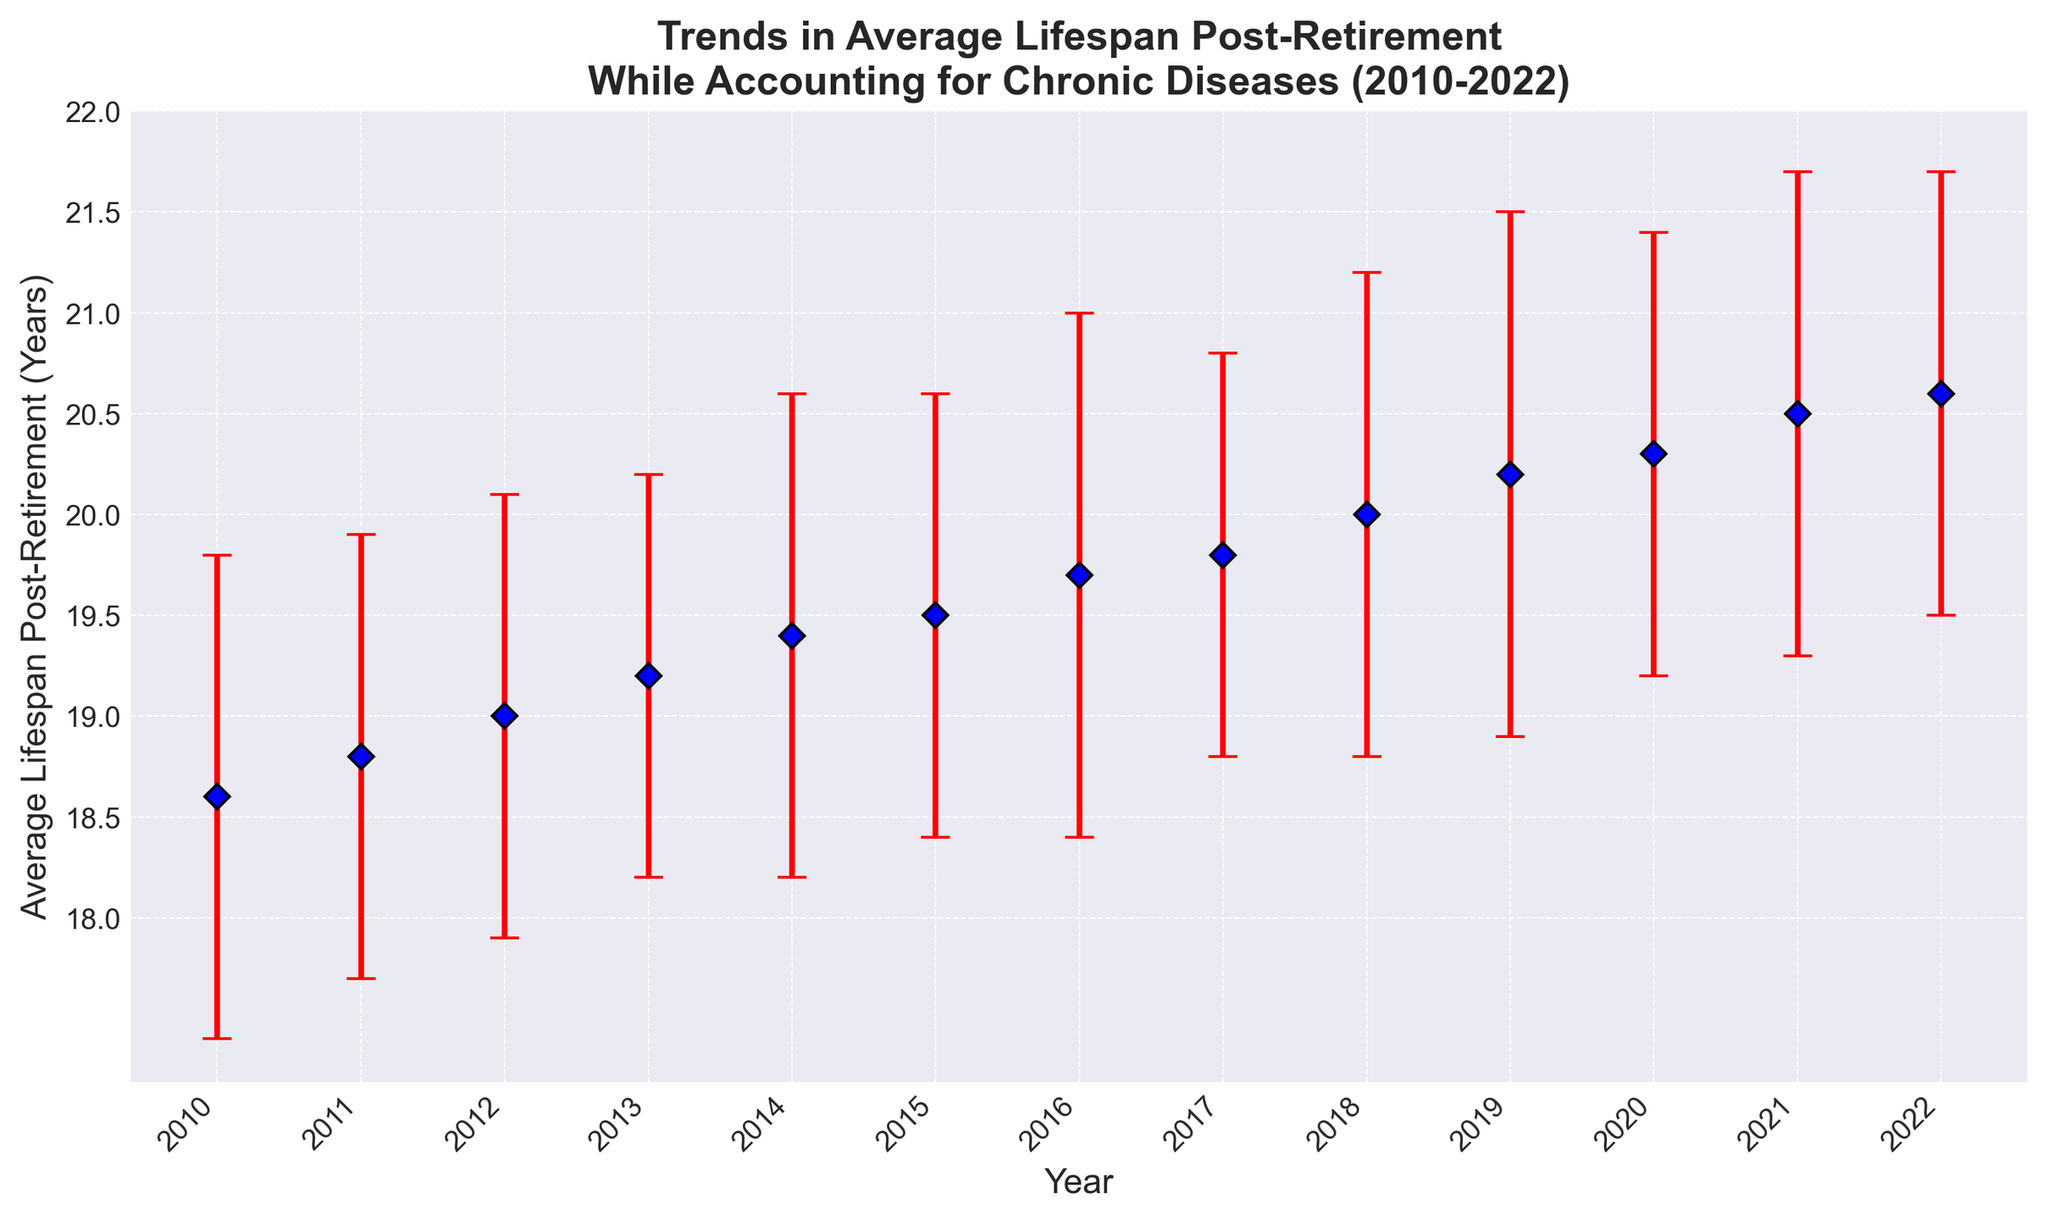What is the general trend in average lifespan post-retirement from 2010 to 2022? The figure shows an increasing trend, with the average lifespan post-retirement rising steadily from 18.6 years in 2010 to 20.6 years in 2022.
Answer: Increasing trend How much did the average lifespan post-retirement increase from 2010 to 2022? To find the increase, subtract the 2010 value from the 2022 value: 20.6 (2022) - 18.6 (2010) = 2.0.
Answer: 2.0 years Which year recorded the highest average lifespan post-retirement? The highest average lifespan post-retirement is recorded in 2022, with a value of 20.6 years.
Answer: 2022 What year had the lowest average lifespan post-retirement, and what was the value? The year 2010 had the lowest average lifespan post-retirement with a value of 18.6 years.
Answer: 2010, 18.6 years How does the average lifespan post-retirement in 2015 compare to that in 2020? The average lifespan post-retirement in 2015 was 19.5 years, and in 2020, it was 20.3 years. Comparing the two, 2020 had a higher value by 0.8 years.
Answer: 2020 is higher by 0.8 years What is the average lifespan post-retirement over the years from 2010 to 2022? To calculate the average, sum all the yearly values and divide by the number of years: (18.6 + 18.8 + 19.0 + 19.2 + 19.4 + 19.5 + 19.7 + 19.8 + 20.0 + 20.2 + 20.3 + 20.5 + 20.6) / 13 = 19.66.
Answer: 19.66 years What is the range of the error values shown in the figure? The range of the error values is found by subtracting the smallest error value from the largest: 1.3 (largest) - 1.0 (smallest) = 0.3.
Answer: 0.3 Which year shows the most significant uncertainty in average lifespan post-retirement? The year with the largest error bar indicates the most significant uncertainty. Both 2016 and 2019 have the largest error bars with a value of 1.3.
Answer: 2016 and 2019 Is there any year where the average lifespan post-retirement stayed the same as the previous year? There is no year where the average lifespan post-retirement stayed the same; it shows a consistent increase each year.
Answer: No What is the total increase in average lifespan post-retirement from 2010 to 2015? To find the total increase, subtract the 2010 value from the 2015 value: 19.5 (2015) - 18.6 (2010) = 0.9.
Answer: 0.9 years 